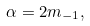<formula> <loc_0><loc_0><loc_500><loc_500>\alpha = 2 m _ { - 1 } ,</formula> 